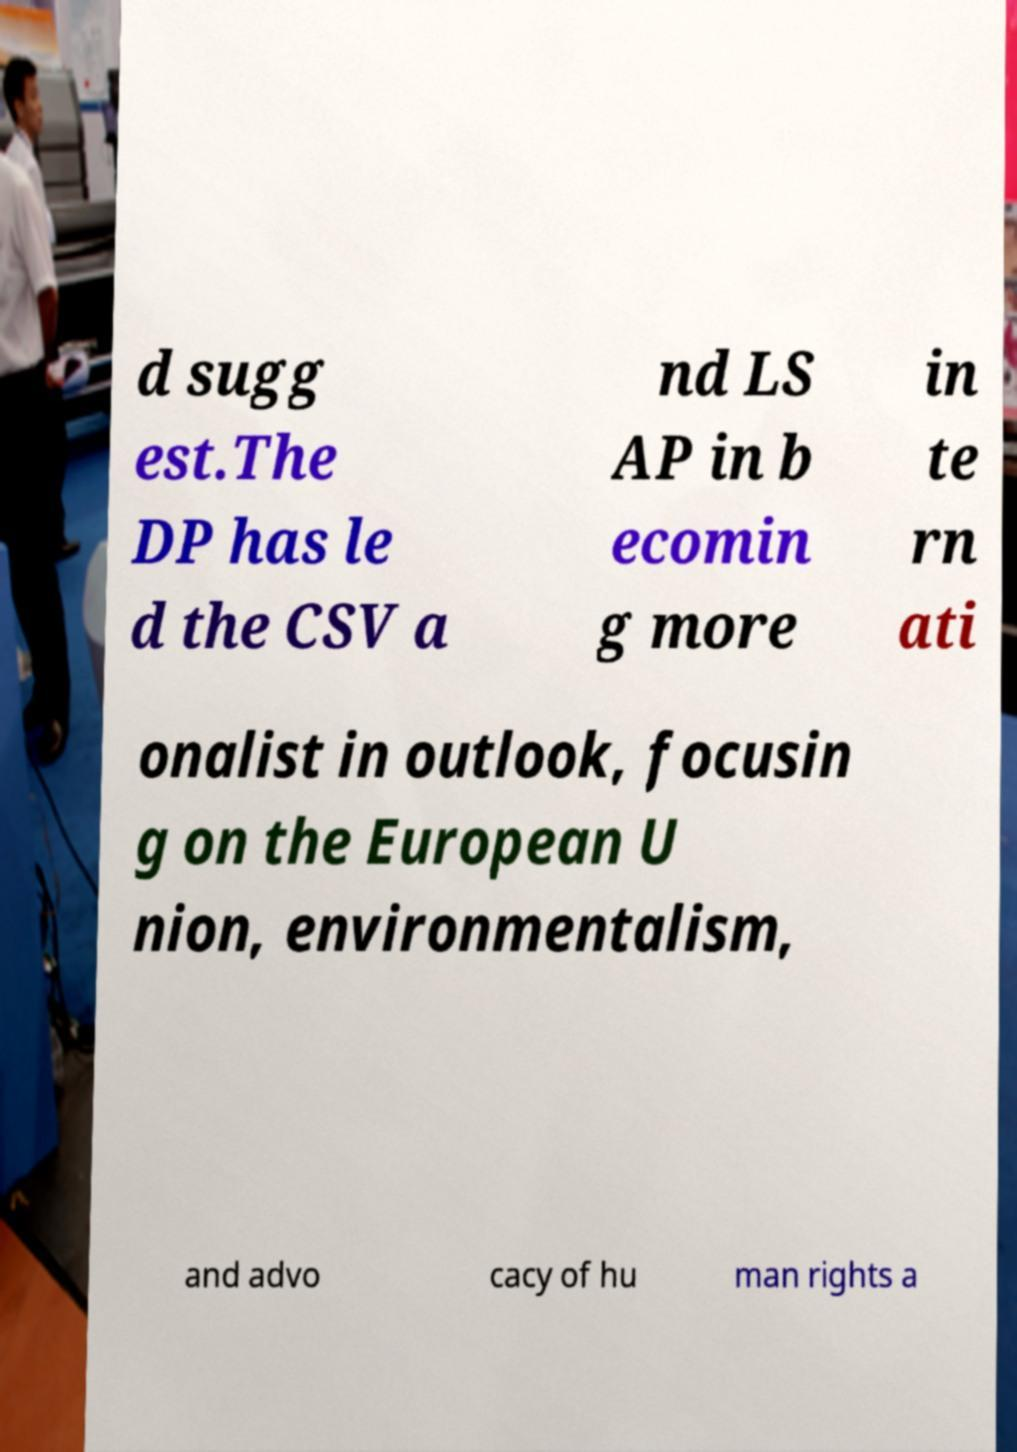For documentation purposes, I need the text within this image transcribed. Could you provide that? d sugg est.The DP has le d the CSV a nd LS AP in b ecomin g more in te rn ati onalist in outlook, focusin g on the European U nion, environmentalism, and advo cacy of hu man rights a 